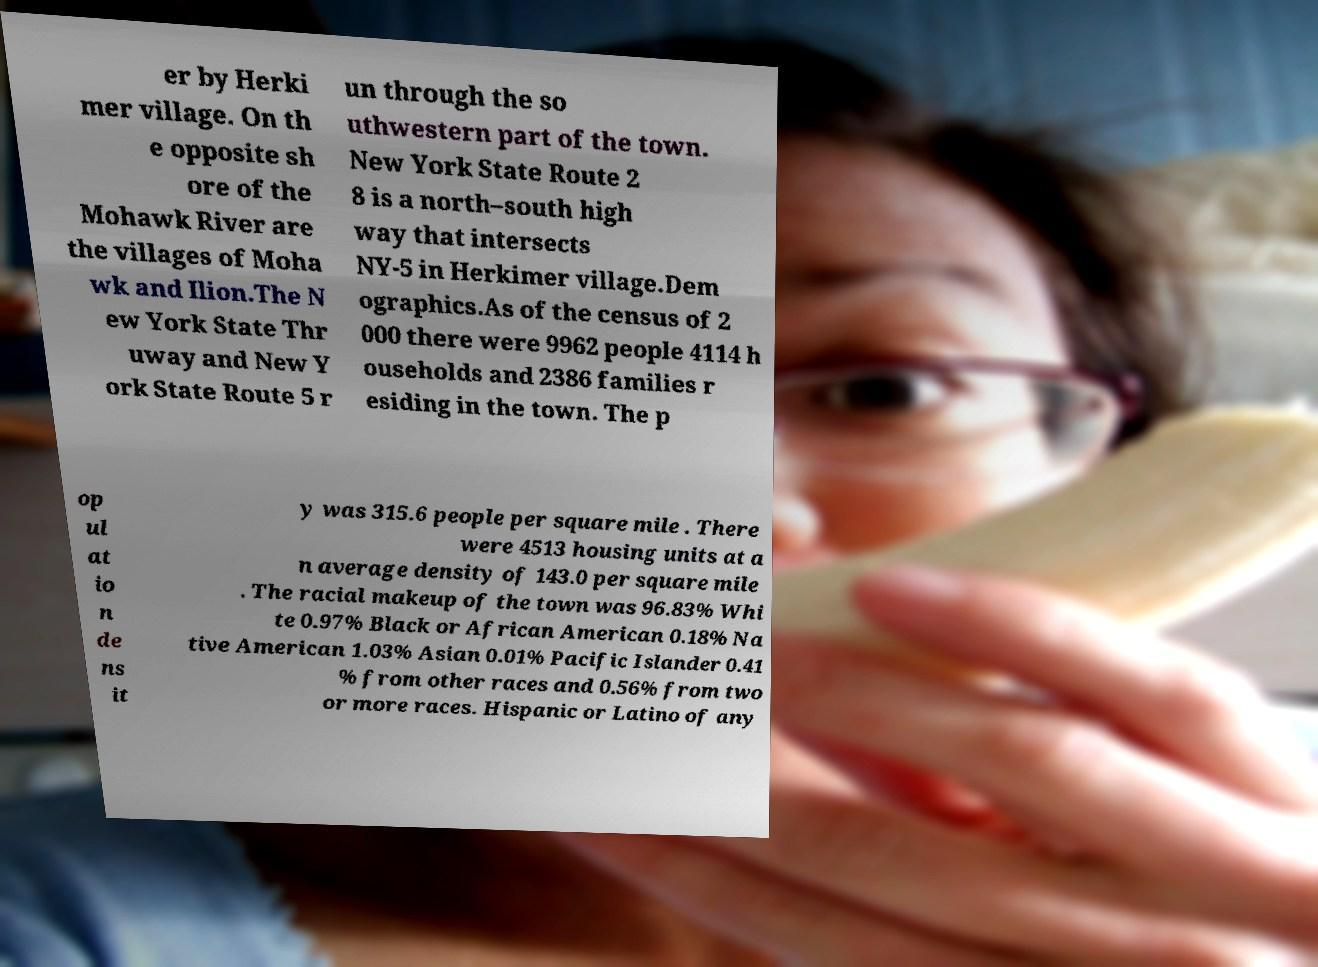I need the written content from this picture converted into text. Can you do that? er by Herki mer village. On th e opposite sh ore of the Mohawk River are the villages of Moha wk and Ilion.The N ew York State Thr uway and New Y ork State Route 5 r un through the so uthwestern part of the town. New York State Route 2 8 is a north–south high way that intersects NY-5 in Herkimer village.Dem ographics.As of the census of 2 000 there were 9962 people 4114 h ouseholds and 2386 families r esiding in the town. The p op ul at io n de ns it y was 315.6 people per square mile . There were 4513 housing units at a n average density of 143.0 per square mile . The racial makeup of the town was 96.83% Whi te 0.97% Black or African American 0.18% Na tive American 1.03% Asian 0.01% Pacific Islander 0.41 % from other races and 0.56% from two or more races. Hispanic or Latino of any 